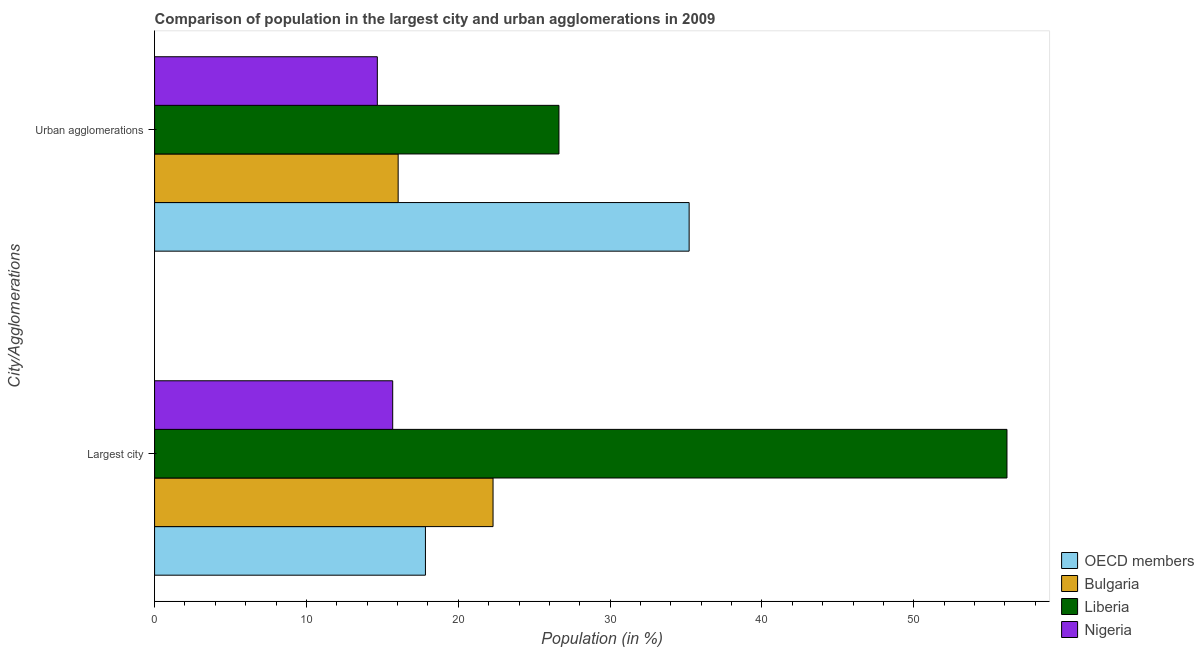How many groups of bars are there?
Your response must be concise. 2. Are the number of bars per tick equal to the number of legend labels?
Keep it short and to the point. Yes. Are the number of bars on each tick of the Y-axis equal?
Your answer should be very brief. Yes. How many bars are there on the 1st tick from the top?
Keep it short and to the point. 4. What is the label of the 1st group of bars from the top?
Keep it short and to the point. Urban agglomerations. What is the population in urban agglomerations in OECD members?
Your answer should be compact. 35.2. Across all countries, what is the maximum population in the largest city?
Give a very brief answer. 56.13. Across all countries, what is the minimum population in the largest city?
Your answer should be very brief. 15.68. In which country was the population in the largest city minimum?
Provide a succinct answer. Nigeria. What is the total population in urban agglomerations in the graph?
Offer a terse response. 92.54. What is the difference between the population in the largest city in Bulgaria and that in Nigeria?
Ensure brevity in your answer.  6.61. What is the difference between the population in urban agglomerations in OECD members and the population in the largest city in Nigeria?
Your response must be concise. 19.52. What is the average population in urban agglomerations per country?
Provide a succinct answer. 23.14. What is the difference between the population in urban agglomerations and population in the largest city in OECD members?
Ensure brevity in your answer.  17.37. In how many countries, is the population in the largest city greater than 40 %?
Make the answer very short. 1. What is the ratio of the population in urban agglomerations in Liberia to that in Bulgaria?
Provide a short and direct response. 1.66. In how many countries, is the population in the largest city greater than the average population in the largest city taken over all countries?
Offer a terse response. 1. What does the 4th bar from the top in Urban agglomerations represents?
Keep it short and to the point. OECD members. What does the 3rd bar from the bottom in Urban agglomerations represents?
Make the answer very short. Liberia. How many bars are there?
Provide a short and direct response. 8. How many countries are there in the graph?
Your answer should be compact. 4. Are the values on the major ticks of X-axis written in scientific E-notation?
Provide a short and direct response. No. Does the graph contain any zero values?
Provide a succinct answer. No. Does the graph contain grids?
Provide a short and direct response. No. How many legend labels are there?
Offer a very short reply. 4. What is the title of the graph?
Ensure brevity in your answer.  Comparison of population in the largest city and urban agglomerations in 2009. What is the label or title of the Y-axis?
Provide a succinct answer. City/Agglomerations. What is the Population (in %) in OECD members in Largest city?
Ensure brevity in your answer.  17.84. What is the Population (in %) in Bulgaria in Largest city?
Offer a terse response. 22.29. What is the Population (in %) of Liberia in Largest city?
Your response must be concise. 56.13. What is the Population (in %) of Nigeria in Largest city?
Make the answer very short. 15.68. What is the Population (in %) of OECD members in Urban agglomerations?
Ensure brevity in your answer.  35.2. What is the Population (in %) of Bulgaria in Urban agglomerations?
Offer a terse response. 16.04. What is the Population (in %) in Liberia in Urban agglomerations?
Provide a succinct answer. 26.63. What is the Population (in %) in Nigeria in Urban agglomerations?
Keep it short and to the point. 14.67. Across all City/Agglomerations, what is the maximum Population (in %) of OECD members?
Make the answer very short. 35.2. Across all City/Agglomerations, what is the maximum Population (in %) in Bulgaria?
Give a very brief answer. 22.29. Across all City/Agglomerations, what is the maximum Population (in %) of Liberia?
Offer a very short reply. 56.13. Across all City/Agglomerations, what is the maximum Population (in %) in Nigeria?
Offer a very short reply. 15.68. Across all City/Agglomerations, what is the minimum Population (in %) in OECD members?
Make the answer very short. 17.84. Across all City/Agglomerations, what is the minimum Population (in %) of Bulgaria?
Give a very brief answer. 16.04. Across all City/Agglomerations, what is the minimum Population (in %) of Liberia?
Your response must be concise. 26.63. Across all City/Agglomerations, what is the minimum Population (in %) in Nigeria?
Your response must be concise. 14.67. What is the total Population (in %) in OECD members in the graph?
Your answer should be compact. 53.04. What is the total Population (in %) of Bulgaria in the graph?
Make the answer very short. 38.33. What is the total Population (in %) of Liberia in the graph?
Your answer should be very brief. 82.76. What is the total Population (in %) of Nigeria in the graph?
Provide a short and direct response. 30.35. What is the difference between the Population (in %) of OECD members in Largest city and that in Urban agglomerations?
Your answer should be very brief. -17.37. What is the difference between the Population (in %) of Bulgaria in Largest city and that in Urban agglomerations?
Keep it short and to the point. 6.25. What is the difference between the Population (in %) of Liberia in Largest city and that in Urban agglomerations?
Keep it short and to the point. 29.5. What is the difference between the Population (in %) in Nigeria in Largest city and that in Urban agglomerations?
Offer a very short reply. 1.01. What is the difference between the Population (in %) in OECD members in Largest city and the Population (in %) in Bulgaria in Urban agglomerations?
Your response must be concise. 1.8. What is the difference between the Population (in %) in OECD members in Largest city and the Population (in %) in Liberia in Urban agglomerations?
Your answer should be very brief. -8.79. What is the difference between the Population (in %) of OECD members in Largest city and the Population (in %) of Nigeria in Urban agglomerations?
Provide a short and direct response. 3.17. What is the difference between the Population (in %) of Bulgaria in Largest city and the Population (in %) of Liberia in Urban agglomerations?
Keep it short and to the point. -4.34. What is the difference between the Population (in %) of Bulgaria in Largest city and the Population (in %) of Nigeria in Urban agglomerations?
Ensure brevity in your answer.  7.62. What is the difference between the Population (in %) of Liberia in Largest city and the Population (in %) of Nigeria in Urban agglomerations?
Make the answer very short. 41.46. What is the average Population (in %) in OECD members per City/Agglomerations?
Provide a succinct answer. 26.52. What is the average Population (in %) in Bulgaria per City/Agglomerations?
Ensure brevity in your answer.  19.17. What is the average Population (in %) of Liberia per City/Agglomerations?
Your answer should be compact. 41.38. What is the average Population (in %) of Nigeria per City/Agglomerations?
Offer a terse response. 15.18. What is the difference between the Population (in %) in OECD members and Population (in %) in Bulgaria in Largest city?
Provide a short and direct response. -4.45. What is the difference between the Population (in %) of OECD members and Population (in %) of Liberia in Largest city?
Keep it short and to the point. -38.3. What is the difference between the Population (in %) of OECD members and Population (in %) of Nigeria in Largest city?
Offer a terse response. 2.16. What is the difference between the Population (in %) of Bulgaria and Population (in %) of Liberia in Largest city?
Ensure brevity in your answer.  -33.84. What is the difference between the Population (in %) in Bulgaria and Population (in %) in Nigeria in Largest city?
Provide a succinct answer. 6.61. What is the difference between the Population (in %) of Liberia and Population (in %) of Nigeria in Largest city?
Ensure brevity in your answer.  40.45. What is the difference between the Population (in %) of OECD members and Population (in %) of Bulgaria in Urban agglomerations?
Your response must be concise. 19.16. What is the difference between the Population (in %) of OECD members and Population (in %) of Liberia in Urban agglomerations?
Make the answer very short. 8.57. What is the difference between the Population (in %) in OECD members and Population (in %) in Nigeria in Urban agglomerations?
Your answer should be compact. 20.53. What is the difference between the Population (in %) of Bulgaria and Population (in %) of Liberia in Urban agglomerations?
Offer a very short reply. -10.59. What is the difference between the Population (in %) in Bulgaria and Population (in %) in Nigeria in Urban agglomerations?
Your answer should be compact. 1.37. What is the difference between the Population (in %) of Liberia and Population (in %) of Nigeria in Urban agglomerations?
Offer a terse response. 11.96. What is the ratio of the Population (in %) of OECD members in Largest city to that in Urban agglomerations?
Offer a very short reply. 0.51. What is the ratio of the Population (in %) of Bulgaria in Largest city to that in Urban agglomerations?
Provide a short and direct response. 1.39. What is the ratio of the Population (in %) of Liberia in Largest city to that in Urban agglomerations?
Offer a terse response. 2.11. What is the ratio of the Population (in %) in Nigeria in Largest city to that in Urban agglomerations?
Your response must be concise. 1.07. What is the difference between the highest and the second highest Population (in %) in OECD members?
Give a very brief answer. 17.37. What is the difference between the highest and the second highest Population (in %) in Bulgaria?
Provide a succinct answer. 6.25. What is the difference between the highest and the second highest Population (in %) of Liberia?
Offer a very short reply. 29.5. What is the difference between the highest and the second highest Population (in %) of Nigeria?
Provide a succinct answer. 1.01. What is the difference between the highest and the lowest Population (in %) of OECD members?
Make the answer very short. 17.37. What is the difference between the highest and the lowest Population (in %) of Bulgaria?
Your response must be concise. 6.25. What is the difference between the highest and the lowest Population (in %) of Liberia?
Give a very brief answer. 29.5. What is the difference between the highest and the lowest Population (in %) of Nigeria?
Give a very brief answer. 1.01. 